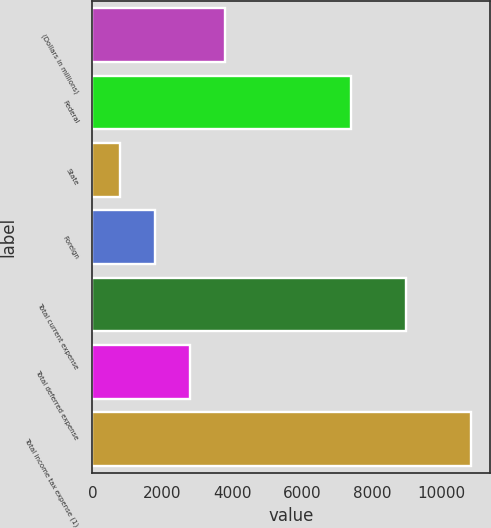<chart> <loc_0><loc_0><loc_500><loc_500><bar_chart><fcel>(Dollars in millions)<fcel>Federal<fcel>State<fcel>Foreign<fcel>Total current expense<fcel>Total deferred expense<fcel>Total income tax expense (1)<nl><fcel>3809.2<fcel>7398<fcel>796<fcel>1800.4<fcel>8990<fcel>2804.8<fcel>10840<nl></chart> 